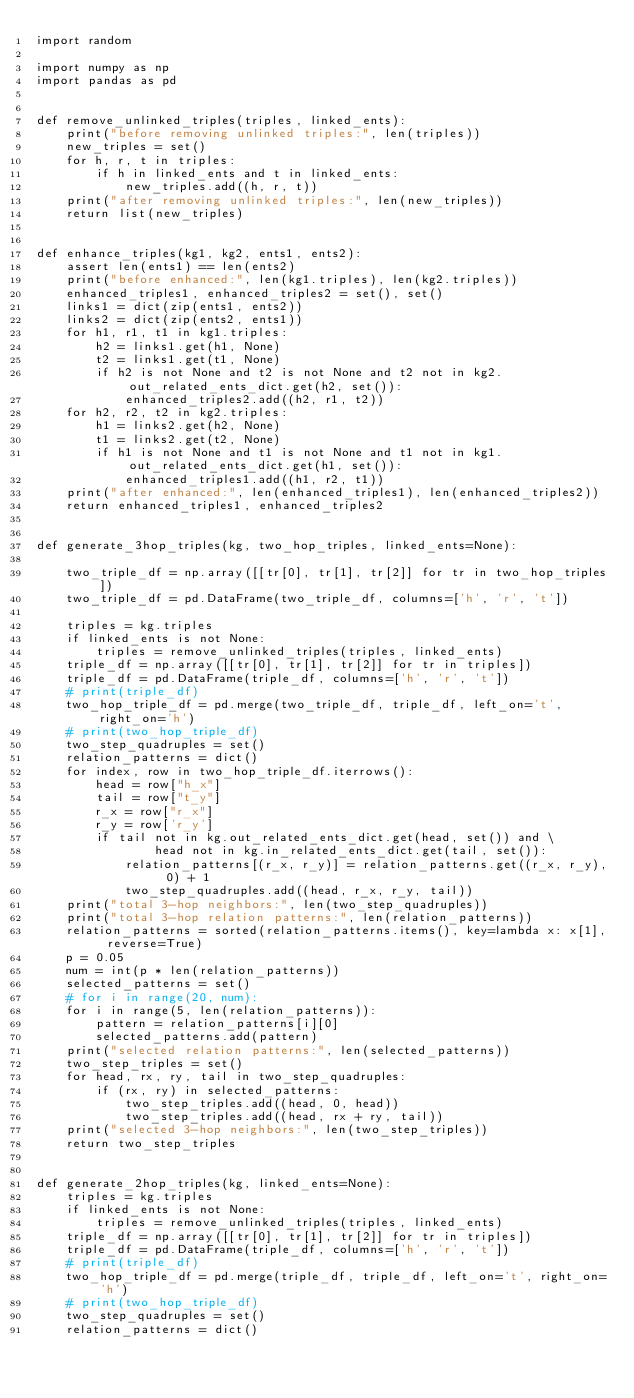Convert code to text. <code><loc_0><loc_0><loc_500><loc_500><_Python_>import random

import numpy as np
import pandas as pd


def remove_unlinked_triples(triples, linked_ents):
    print("before removing unlinked triples:", len(triples))
    new_triples = set()
    for h, r, t in triples:
        if h in linked_ents and t in linked_ents:
            new_triples.add((h, r, t))
    print("after removing unlinked triples:", len(new_triples))
    return list(new_triples)


def enhance_triples(kg1, kg2, ents1, ents2):
    assert len(ents1) == len(ents2)
    print("before enhanced:", len(kg1.triples), len(kg2.triples))
    enhanced_triples1, enhanced_triples2 = set(), set()
    links1 = dict(zip(ents1, ents2))
    links2 = dict(zip(ents2, ents1))
    for h1, r1, t1 in kg1.triples:
        h2 = links1.get(h1, None)
        t2 = links1.get(t1, None)
        if h2 is not None and t2 is not None and t2 not in kg2.out_related_ents_dict.get(h2, set()):
            enhanced_triples2.add((h2, r1, t2))
    for h2, r2, t2 in kg2.triples:
        h1 = links2.get(h2, None)
        t1 = links2.get(t2, None)
        if h1 is not None and t1 is not None and t1 not in kg1.out_related_ents_dict.get(h1, set()):
            enhanced_triples1.add((h1, r2, t1))
    print("after enhanced:", len(enhanced_triples1), len(enhanced_triples2))
    return enhanced_triples1, enhanced_triples2


def generate_3hop_triples(kg, two_hop_triples, linked_ents=None):

    two_triple_df = np.array([[tr[0], tr[1], tr[2]] for tr in two_hop_triples])
    two_triple_df = pd.DataFrame(two_triple_df, columns=['h', 'r', 't'])

    triples = kg.triples
    if linked_ents is not None:
        triples = remove_unlinked_triples(triples, linked_ents)
    triple_df = np.array([[tr[0], tr[1], tr[2]] for tr in triples])
    triple_df = pd.DataFrame(triple_df, columns=['h', 'r', 't'])
    # print(triple_df)
    two_hop_triple_df = pd.merge(two_triple_df, triple_df, left_on='t', right_on='h')
    # print(two_hop_triple_df)
    two_step_quadruples = set()
    relation_patterns = dict()
    for index, row in two_hop_triple_df.iterrows():
        head = row["h_x"]
        tail = row["t_y"]
        r_x = row["r_x"]
        r_y = row['r_y']
        if tail not in kg.out_related_ents_dict.get(head, set()) and \
                head not in kg.in_related_ents_dict.get(tail, set()):
            relation_patterns[(r_x, r_y)] = relation_patterns.get((r_x, r_y), 0) + 1
            two_step_quadruples.add((head, r_x, r_y, tail))
    print("total 3-hop neighbors:", len(two_step_quadruples))
    print("total 3-hop relation patterns:", len(relation_patterns))
    relation_patterns = sorted(relation_patterns.items(), key=lambda x: x[1], reverse=True)
    p = 0.05
    num = int(p * len(relation_patterns))
    selected_patterns = set()
    # for i in range(20, num):
    for i in range(5, len(relation_patterns)):
        pattern = relation_patterns[i][0]
        selected_patterns.add(pattern)
    print("selected relation patterns:", len(selected_patterns))
    two_step_triples = set()
    for head, rx, ry, tail in two_step_quadruples:
        if (rx, ry) in selected_patterns:
            two_step_triples.add((head, 0, head))
            two_step_triples.add((head, rx + ry, tail))
    print("selected 3-hop neighbors:", len(two_step_triples))
    return two_step_triples


def generate_2hop_triples(kg, linked_ents=None):
    triples = kg.triples
    if linked_ents is not None:
        triples = remove_unlinked_triples(triples, linked_ents)
    triple_df = np.array([[tr[0], tr[1], tr[2]] for tr in triples])
    triple_df = pd.DataFrame(triple_df, columns=['h', 'r', 't'])
    # print(triple_df)
    two_hop_triple_df = pd.merge(triple_df, triple_df, left_on='t', right_on='h')
    # print(two_hop_triple_df)
    two_step_quadruples = set()
    relation_patterns = dict()</code> 